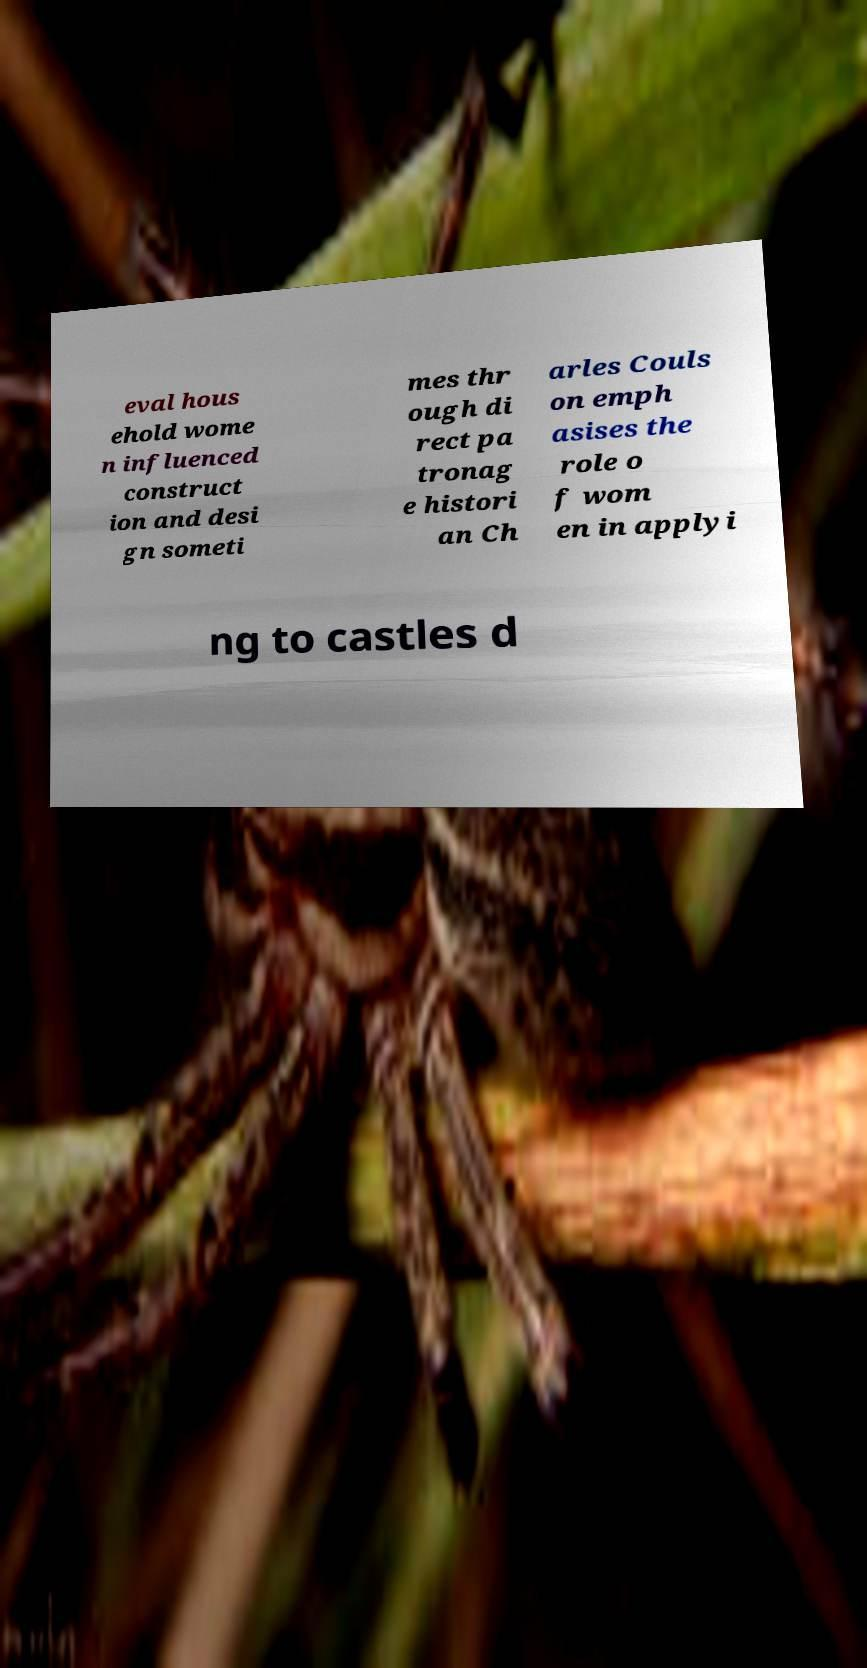Could you assist in decoding the text presented in this image and type it out clearly? eval hous ehold wome n influenced construct ion and desi gn someti mes thr ough di rect pa tronag e histori an Ch arles Couls on emph asises the role o f wom en in applyi ng to castles d 